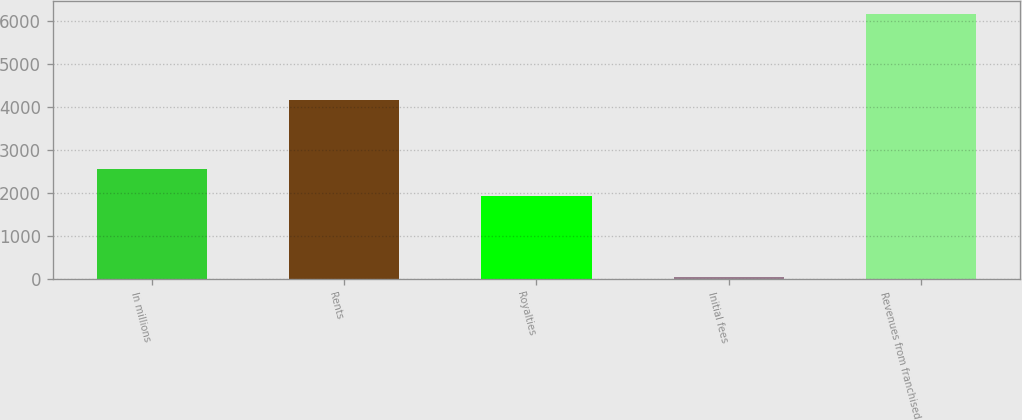<chart> <loc_0><loc_0><loc_500><loc_500><bar_chart><fcel>In millions<fcel>Rents<fcel>Royalties<fcel>Initial fees<fcel>Revenues from franchised<nl><fcel>2552.93<fcel>4177.2<fcel>1941.1<fcel>57.3<fcel>6175.6<nl></chart> 